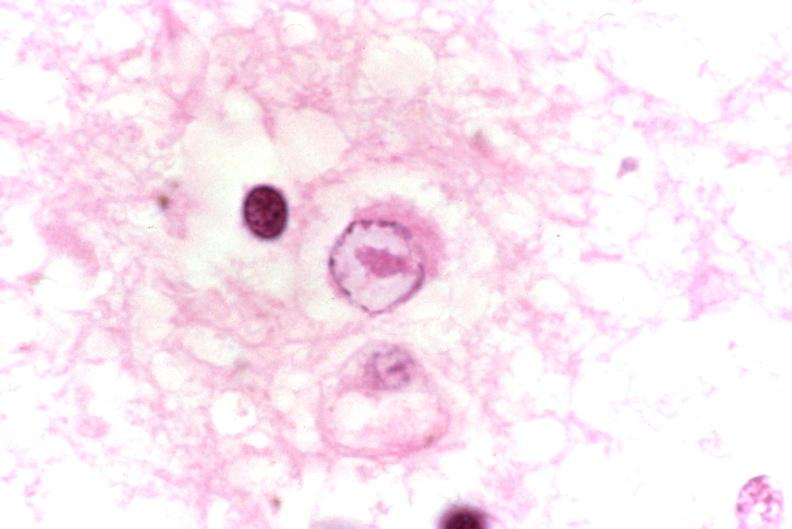does this image show brain, herpes encephalitis, intranuclear inclusion body?
Answer the question using a single word or phrase. Yes 